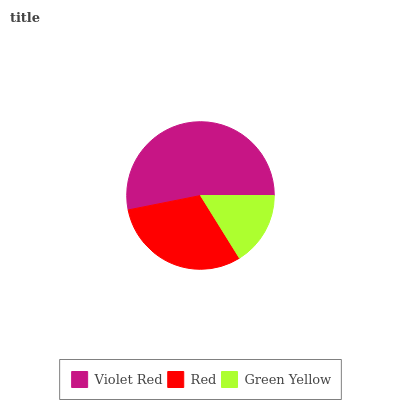Is Green Yellow the minimum?
Answer yes or no. Yes. Is Violet Red the maximum?
Answer yes or no. Yes. Is Red the minimum?
Answer yes or no. No. Is Red the maximum?
Answer yes or no. No. Is Violet Red greater than Red?
Answer yes or no. Yes. Is Red less than Violet Red?
Answer yes or no. Yes. Is Red greater than Violet Red?
Answer yes or no. No. Is Violet Red less than Red?
Answer yes or no. No. Is Red the high median?
Answer yes or no. Yes. Is Red the low median?
Answer yes or no. Yes. Is Green Yellow the high median?
Answer yes or no. No. Is Violet Red the low median?
Answer yes or no. No. 